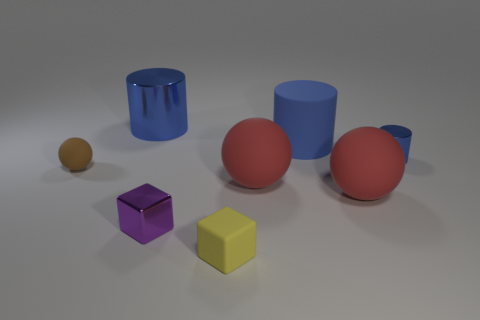What materials look like they've been used to create these objects? The objects appear to be made of materials with different textures: the spheres and cylinders have a matte finish suggesting a clay or plastic material, and the cubes have a slightly shinier surface indicative of a polished metal or plastic. 